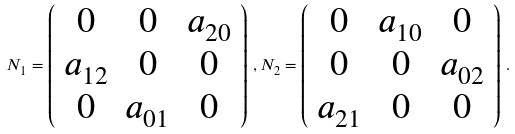Convert formula to latex. <formula><loc_0><loc_0><loc_500><loc_500>N _ { 1 } = \left ( \begin{array} { c c c } 0 & 0 & a _ { 2 0 } \\ a _ { 1 2 } & 0 & 0 \\ 0 & a _ { 0 1 } & 0 \end{array} \right ) \, , N _ { 2 } = \left ( \begin{array} { c c c } 0 & a _ { 1 0 } & 0 \\ 0 & 0 & a _ { 0 2 } \\ a _ { 2 1 } & 0 & 0 \end{array} \right ) \, .</formula> 